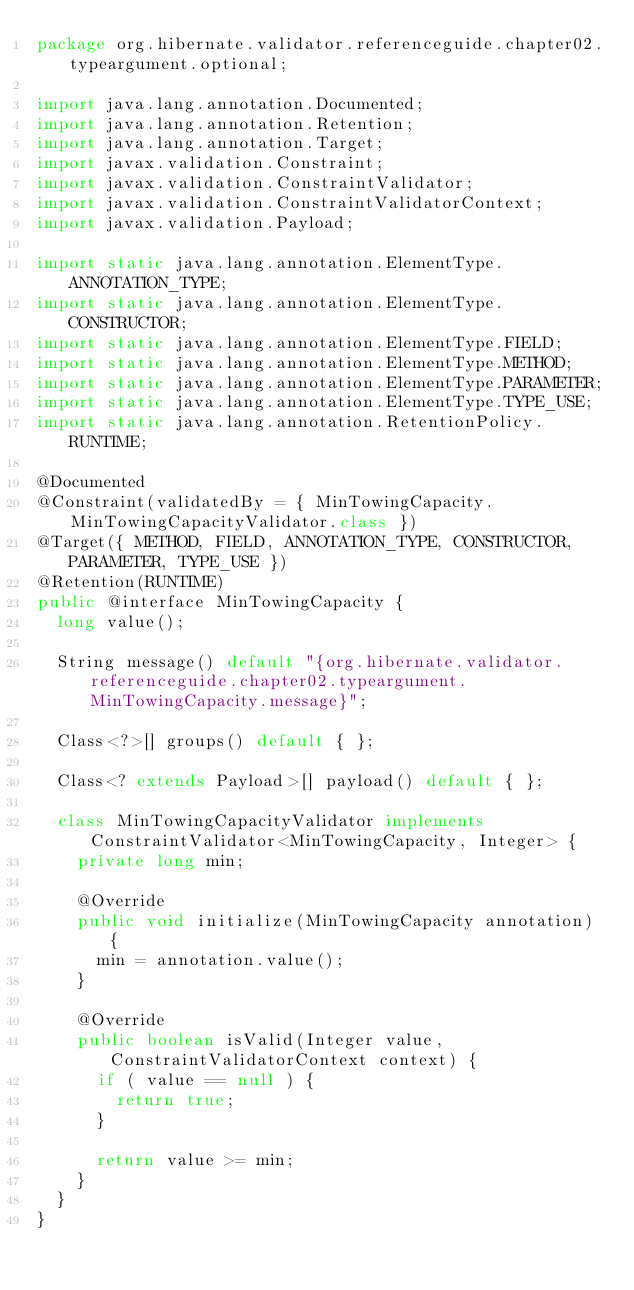<code> <loc_0><loc_0><loc_500><loc_500><_Java_>package org.hibernate.validator.referenceguide.chapter02.typeargument.optional;

import java.lang.annotation.Documented;
import java.lang.annotation.Retention;
import java.lang.annotation.Target;
import javax.validation.Constraint;
import javax.validation.ConstraintValidator;
import javax.validation.ConstraintValidatorContext;
import javax.validation.Payload;

import static java.lang.annotation.ElementType.ANNOTATION_TYPE;
import static java.lang.annotation.ElementType.CONSTRUCTOR;
import static java.lang.annotation.ElementType.FIELD;
import static java.lang.annotation.ElementType.METHOD;
import static java.lang.annotation.ElementType.PARAMETER;
import static java.lang.annotation.ElementType.TYPE_USE;
import static java.lang.annotation.RetentionPolicy.RUNTIME;

@Documented
@Constraint(validatedBy = { MinTowingCapacity.MinTowingCapacityValidator.class })
@Target({ METHOD, FIELD, ANNOTATION_TYPE, CONSTRUCTOR, PARAMETER, TYPE_USE })
@Retention(RUNTIME)
public @interface MinTowingCapacity {
	long value();

	String message() default "{org.hibernate.validator.referenceguide.chapter02.typeargument.MinTowingCapacity.message}";

	Class<?>[] groups() default { };

	Class<? extends Payload>[] payload() default { };

	class MinTowingCapacityValidator implements ConstraintValidator<MinTowingCapacity, Integer> {
		private long min;

		@Override
		public void initialize(MinTowingCapacity annotation) {
			min = annotation.value();
		}

		@Override
		public boolean isValid(Integer value, ConstraintValidatorContext context) {
			if ( value == null ) {
				return true;
			}

			return value >= min;
		}
	}
}
</code> 